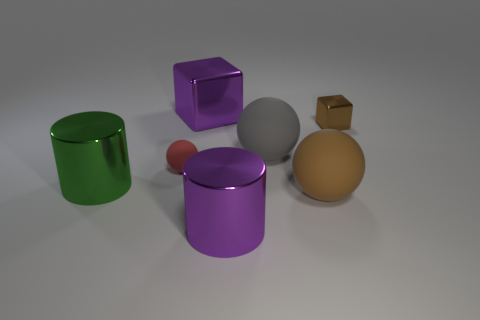Subtract all gray matte spheres. How many spheres are left? 2 Add 3 balls. How many objects exist? 10 Subtract all purple blocks. How many blocks are left? 1 Subtract all spheres. How many objects are left? 4 Subtract 1 cylinders. How many cylinders are left? 1 Subtract all red blocks. Subtract all blue spheres. How many blocks are left? 2 Subtract all brown balls. How many green cubes are left? 0 Add 3 shiny blocks. How many shiny blocks are left? 5 Add 4 small brown objects. How many small brown objects exist? 5 Subtract 0 yellow cylinders. How many objects are left? 7 